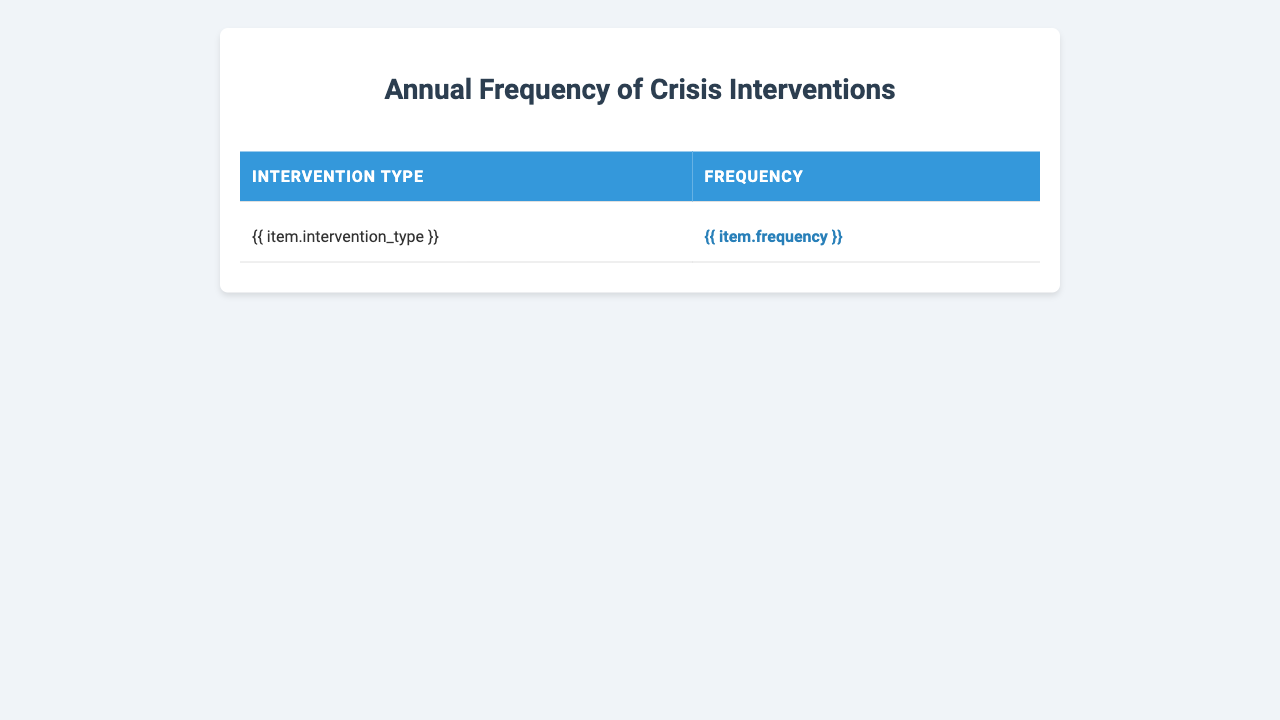What is the type of crisis intervention with the highest frequency? By looking at the table, we see that "Domestic violence support" has the highest frequency of 203, which is greater than all other intervention types.
Answer: Domestic violence support How many crisis interventions were performed for "Child neglect cases"? The table lists "Child neglect cases" with a frequency of 128.
Answer: 128 What is the total frequency of "Foster care placement" and "Grief counseling"? To find the total, we add the frequencies of both interventions: 118 (Foster care placement) + 97 (Grief counseling) = 215.
Answer: 215 Is the frequency for "School shooting aftermath" greater than that of "Natural disaster relief"? The frequency for "School shooting aftermath" is 3, and for "Natural disaster relief," it is 42. Since 3 is less than 42, the statement is false.
Answer: No What is the difference in frequency between "Parental substance abuse" and "Bullying intervention"? The frequency of "Parental substance abuse" is 175, and for "Bullying intervention," it is 108. The difference is 175 - 108 = 67.
Answer: 67 What is the average frequency of the interventions related to child welfare (including "Child abuse response," "Foster care placement," "Child neglect cases," and "Bullying intervention")? The frequencies of the mentioned interventions are 156, 118, 128, and 108. First, we calculate the total: 156 + 118 + 128 + 108 = 510. There are 4 interventions, so the average is 510 / 4 = 127.5.
Answer: 127.5 Which two interventions have frequencies closest to each other? By examining the table, "Family reunification" (85) and "Suicide prevention" (89) have the closest frequencies, with a difference of 4.
Answer: Family reunification and suicide prevention How many more interventions were performed for "Domestic violence support" than for "Community violence response"? The frequency of "Domestic violence support" is 203, and for "Community violence response," it is 53. The difference is 203 - 53 = 150.
Answer: 150 What is the total number of crisis interventions recorded in the table? By adding all frequencies: 156 + 203 + 42 + 3 + 89 + 118 + 175 + 134 + 97 + 128 + 61 + 72 + 108 + 85 + 53 = 1,229.
Answer: 1229 Which intervention has the lowest frequency and what is that frequency? The lowest frequency in the table is "School shooting aftermath," with a frequency of 3.
Answer: School shooting aftermath and 3 